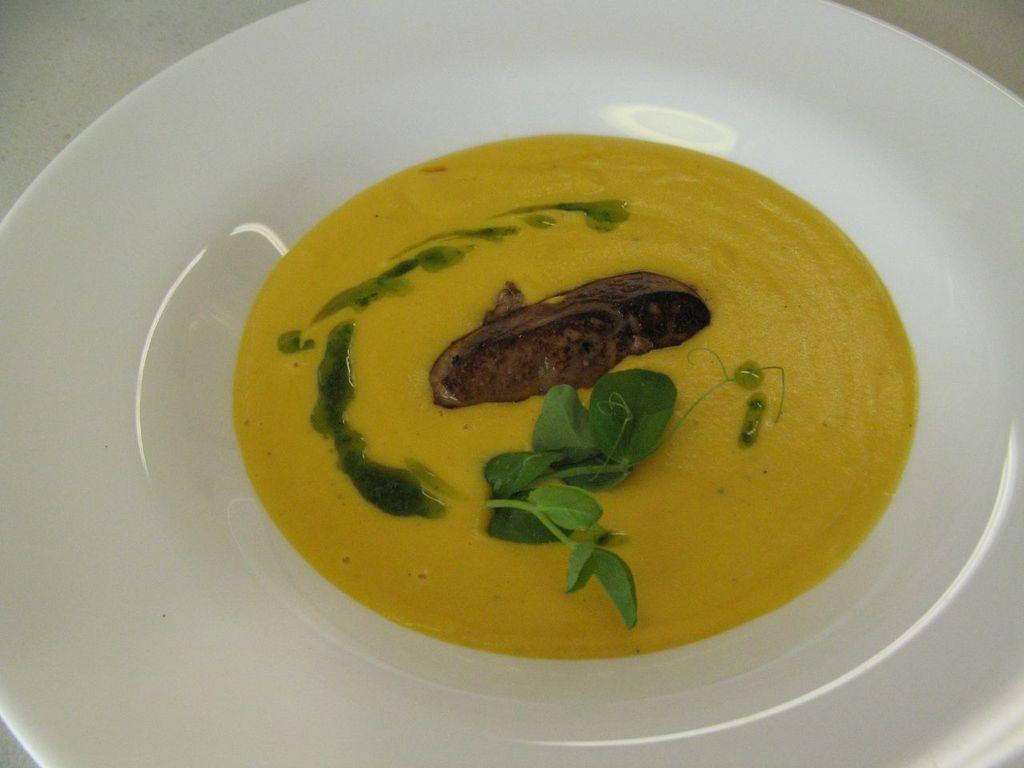What is the main dish visible in the image? There is a soup in the image. How is the soup presented in the image? The soup is in a plate. Where is the plate with the soup located? The plate with the soup is placed on a table. What type of wrench is being used to stir the soup in the image? There is no wrench present in the image, and the soup is not being stirred. What is the tail of the soup made of in the image? There is no tail present in the image, as the soup is not an animal or a creature with a tail. 